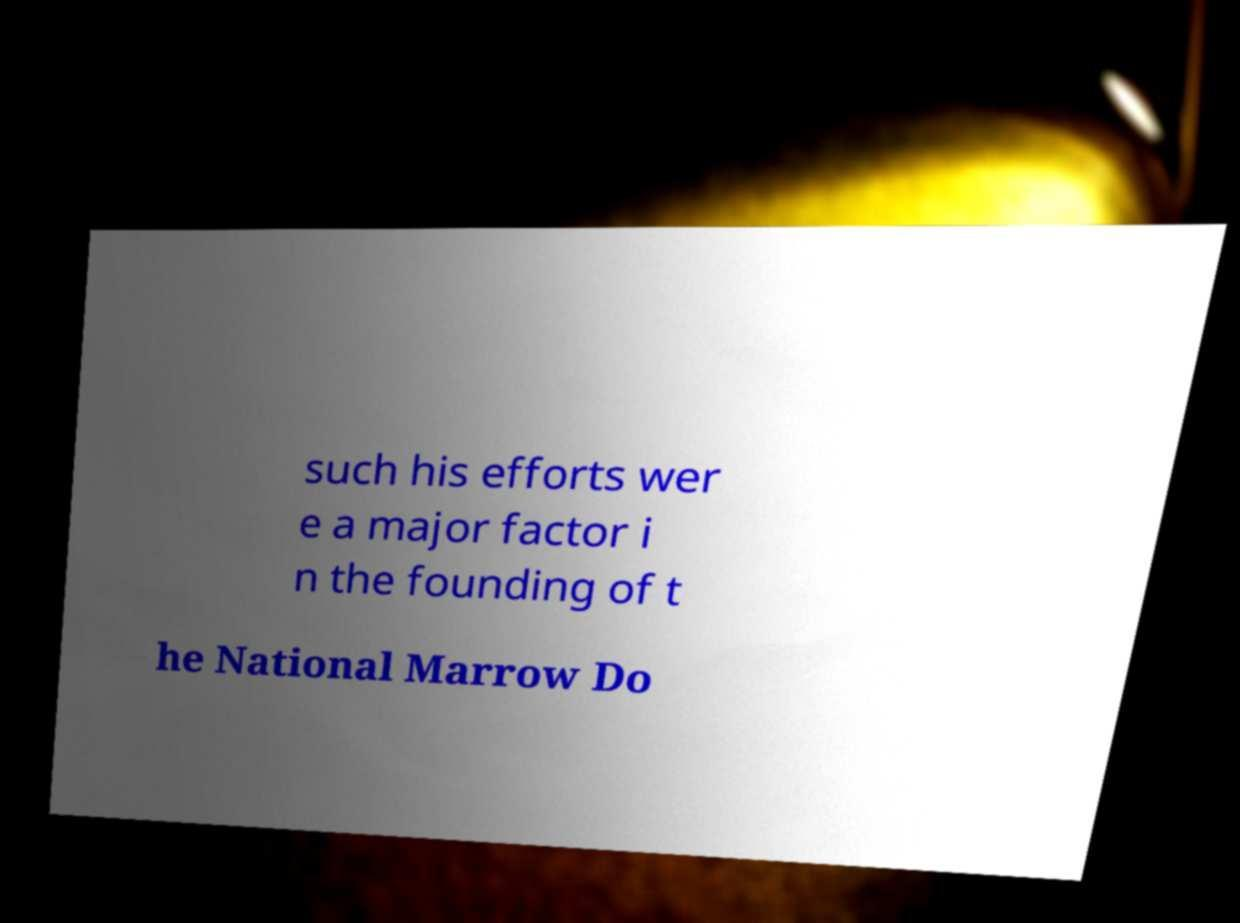Could you assist in decoding the text presented in this image and type it out clearly? such his efforts wer e a major factor i n the founding of t he National Marrow Do 